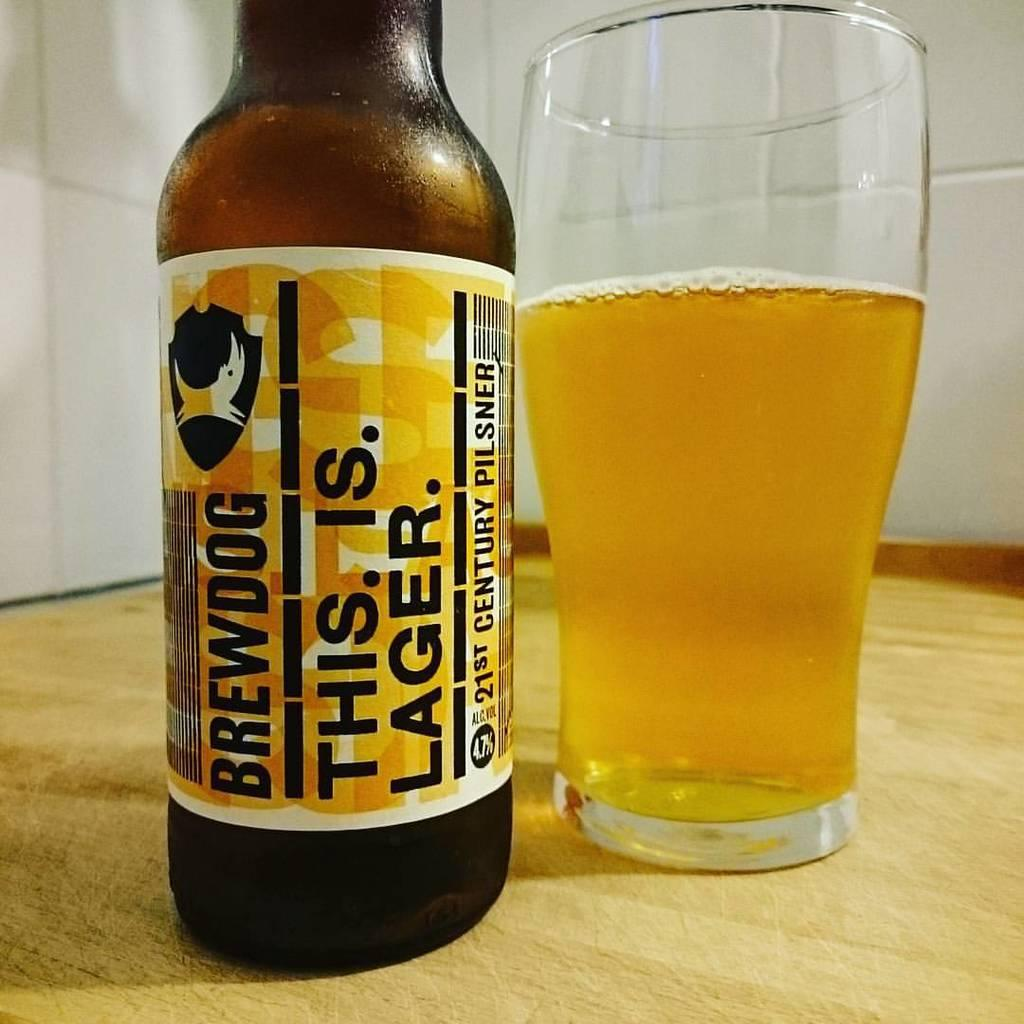<image>
Create a compact narrative representing the image presented. A bottle of Brewdog lager has a yellow label with black writing. 